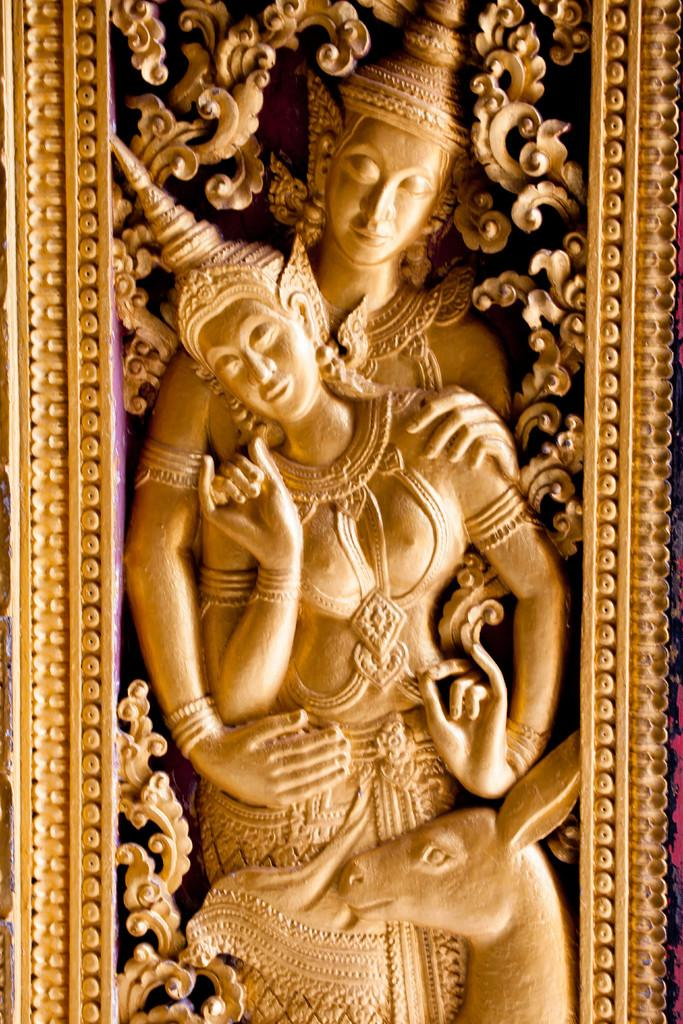What is the main subject of the image? There is a statue representing a human in the image. How many people are present in the image? There are two people in the image. What other living creature can be seen in the image? There is an animal at the bottom of the image. What type of hose is being used by the statue in the image? There is no hose present in the image; the main subject is a statue representing a human. What value does the bag held by one of the people in the image represent? There is no bag present in the image, so it is not possible to determine the value it might represent. 